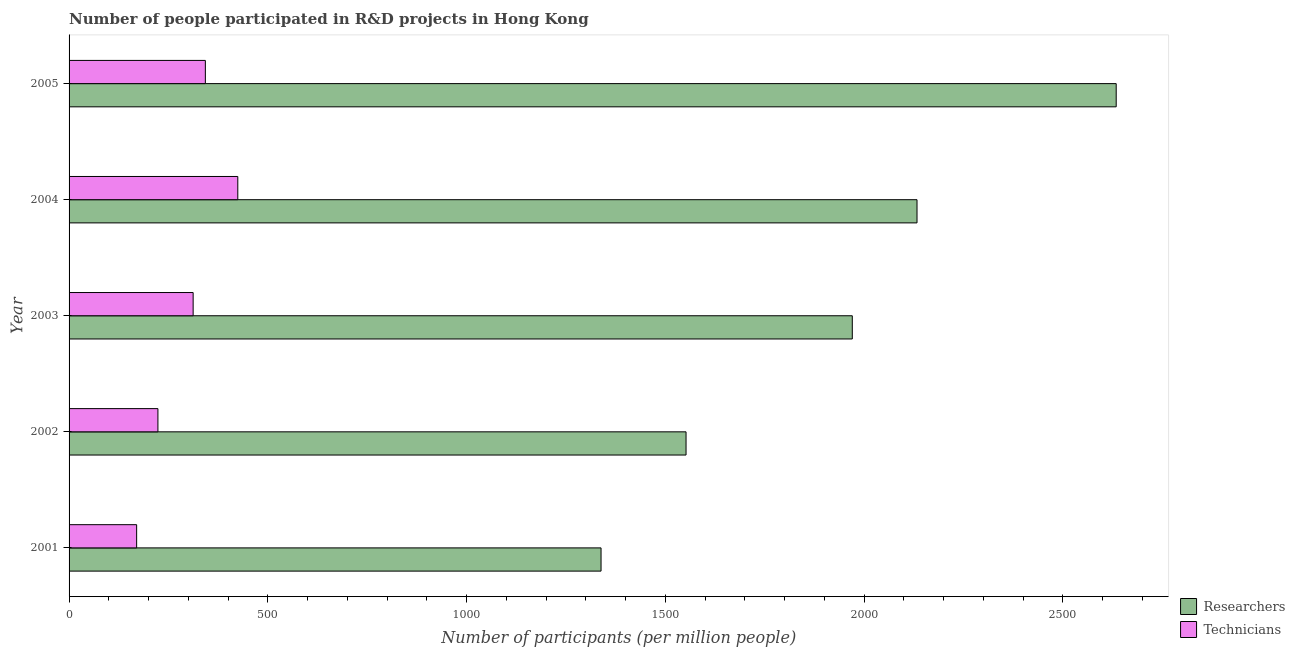How many different coloured bars are there?
Offer a very short reply. 2. How many groups of bars are there?
Provide a succinct answer. 5. How many bars are there on the 2nd tick from the top?
Provide a succinct answer. 2. How many bars are there on the 5th tick from the bottom?
Ensure brevity in your answer.  2. What is the label of the 3rd group of bars from the top?
Offer a very short reply. 2003. What is the number of researchers in 2004?
Keep it short and to the point. 2133.09. Across all years, what is the maximum number of researchers?
Offer a very short reply. 2634.14. Across all years, what is the minimum number of technicians?
Ensure brevity in your answer.  169.97. In which year was the number of technicians maximum?
Ensure brevity in your answer.  2004. What is the total number of researchers in the graph?
Provide a short and direct response. 9627.81. What is the difference between the number of researchers in 2003 and that in 2005?
Your answer should be very brief. -663.88. What is the difference between the number of researchers in 2004 and the number of technicians in 2001?
Your answer should be compact. 1963.12. What is the average number of technicians per year?
Ensure brevity in your answer.  294.58. In the year 2001, what is the difference between the number of technicians and number of researchers?
Your answer should be compact. -1168.28. In how many years, is the number of researchers greater than 600 ?
Give a very brief answer. 5. What is the ratio of the number of technicians in 2001 to that in 2003?
Your response must be concise. 0.55. What is the difference between the highest and the second highest number of technicians?
Keep it short and to the point. 81.6. What is the difference between the highest and the lowest number of technicians?
Your response must be concise. 254.49. What does the 1st bar from the top in 2005 represents?
Your answer should be very brief. Technicians. What does the 2nd bar from the bottom in 2002 represents?
Make the answer very short. Technicians. How many years are there in the graph?
Keep it short and to the point. 5. Does the graph contain any zero values?
Give a very brief answer. No. Does the graph contain grids?
Offer a terse response. No. How many legend labels are there?
Provide a short and direct response. 2. How are the legend labels stacked?
Offer a very short reply. Vertical. What is the title of the graph?
Provide a short and direct response. Number of people participated in R&D projects in Hong Kong. Does "From production" appear as one of the legend labels in the graph?
Your answer should be very brief. No. What is the label or title of the X-axis?
Make the answer very short. Number of participants (per million people). What is the label or title of the Y-axis?
Give a very brief answer. Year. What is the Number of participants (per million people) in Researchers in 2001?
Your response must be concise. 1338.25. What is the Number of participants (per million people) in Technicians in 2001?
Your answer should be very brief. 169.97. What is the Number of participants (per million people) in Researchers in 2002?
Your response must be concise. 1552.06. What is the Number of participants (per million people) in Technicians in 2002?
Offer a terse response. 223.49. What is the Number of participants (per million people) of Researchers in 2003?
Keep it short and to the point. 1970.26. What is the Number of participants (per million people) of Technicians in 2003?
Ensure brevity in your answer.  312.1. What is the Number of participants (per million people) of Researchers in 2004?
Offer a very short reply. 2133.09. What is the Number of participants (per million people) of Technicians in 2004?
Offer a terse response. 424.46. What is the Number of participants (per million people) in Researchers in 2005?
Offer a very short reply. 2634.14. What is the Number of participants (per million people) of Technicians in 2005?
Ensure brevity in your answer.  342.86. Across all years, what is the maximum Number of participants (per million people) in Researchers?
Offer a terse response. 2634.14. Across all years, what is the maximum Number of participants (per million people) in Technicians?
Provide a short and direct response. 424.46. Across all years, what is the minimum Number of participants (per million people) in Researchers?
Your response must be concise. 1338.25. Across all years, what is the minimum Number of participants (per million people) in Technicians?
Your answer should be very brief. 169.97. What is the total Number of participants (per million people) of Researchers in the graph?
Your answer should be very brief. 9627.81. What is the total Number of participants (per million people) of Technicians in the graph?
Your response must be concise. 1472.88. What is the difference between the Number of participants (per million people) of Researchers in 2001 and that in 2002?
Keep it short and to the point. -213.81. What is the difference between the Number of participants (per million people) in Technicians in 2001 and that in 2002?
Provide a short and direct response. -53.53. What is the difference between the Number of participants (per million people) of Researchers in 2001 and that in 2003?
Provide a succinct answer. -632.01. What is the difference between the Number of participants (per million people) in Technicians in 2001 and that in 2003?
Keep it short and to the point. -142.13. What is the difference between the Number of participants (per million people) in Researchers in 2001 and that in 2004?
Give a very brief answer. -794.84. What is the difference between the Number of participants (per million people) in Technicians in 2001 and that in 2004?
Offer a very short reply. -254.49. What is the difference between the Number of participants (per million people) of Researchers in 2001 and that in 2005?
Offer a very short reply. -1295.89. What is the difference between the Number of participants (per million people) in Technicians in 2001 and that in 2005?
Your answer should be very brief. -172.89. What is the difference between the Number of participants (per million people) of Researchers in 2002 and that in 2003?
Offer a terse response. -418.2. What is the difference between the Number of participants (per million people) in Technicians in 2002 and that in 2003?
Offer a terse response. -88.61. What is the difference between the Number of participants (per million people) of Researchers in 2002 and that in 2004?
Provide a short and direct response. -581.03. What is the difference between the Number of participants (per million people) of Technicians in 2002 and that in 2004?
Your response must be concise. -200.96. What is the difference between the Number of participants (per million people) in Researchers in 2002 and that in 2005?
Provide a short and direct response. -1082.08. What is the difference between the Number of participants (per million people) in Technicians in 2002 and that in 2005?
Give a very brief answer. -119.36. What is the difference between the Number of participants (per million people) of Researchers in 2003 and that in 2004?
Provide a short and direct response. -162.83. What is the difference between the Number of participants (per million people) of Technicians in 2003 and that in 2004?
Offer a very short reply. -112.36. What is the difference between the Number of participants (per million people) in Researchers in 2003 and that in 2005?
Offer a very short reply. -663.88. What is the difference between the Number of participants (per million people) in Technicians in 2003 and that in 2005?
Offer a very short reply. -30.76. What is the difference between the Number of participants (per million people) of Researchers in 2004 and that in 2005?
Your answer should be compact. -501.04. What is the difference between the Number of participants (per million people) of Technicians in 2004 and that in 2005?
Give a very brief answer. 81.6. What is the difference between the Number of participants (per million people) in Researchers in 2001 and the Number of participants (per million people) in Technicians in 2002?
Offer a very short reply. 1114.76. What is the difference between the Number of participants (per million people) of Researchers in 2001 and the Number of participants (per million people) of Technicians in 2003?
Your answer should be very brief. 1026.15. What is the difference between the Number of participants (per million people) in Researchers in 2001 and the Number of participants (per million people) in Technicians in 2004?
Your response must be concise. 913.79. What is the difference between the Number of participants (per million people) of Researchers in 2001 and the Number of participants (per million people) of Technicians in 2005?
Your response must be concise. 995.39. What is the difference between the Number of participants (per million people) of Researchers in 2002 and the Number of participants (per million people) of Technicians in 2003?
Offer a very short reply. 1239.96. What is the difference between the Number of participants (per million people) of Researchers in 2002 and the Number of participants (per million people) of Technicians in 2004?
Make the answer very short. 1127.61. What is the difference between the Number of participants (per million people) of Researchers in 2002 and the Number of participants (per million people) of Technicians in 2005?
Your answer should be very brief. 1209.2. What is the difference between the Number of participants (per million people) in Researchers in 2003 and the Number of participants (per million people) in Technicians in 2004?
Keep it short and to the point. 1545.81. What is the difference between the Number of participants (per million people) of Researchers in 2003 and the Number of participants (per million people) of Technicians in 2005?
Provide a succinct answer. 1627.4. What is the difference between the Number of participants (per million people) of Researchers in 2004 and the Number of participants (per million people) of Technicians in 2005?
Offer a terse response. 1790.24. What is the average Number of participants (per million people) in Researchers per year?
Provide a short and direct response. 1925.56. What is the average Number of participants (per million people) of Technicians per year?
Your answer should be very brief. 294.58. In the year 2001, what is the difference between the Number of participants (per million people) in Researchers and Number of participants (per million people) in Technicians?
Give a very brief answer. 1168.28. In the year 2002, what is the difference between the Number of participants (per million people) of Researchers and Number of participants (per million people) of Technicians?
Keep it short and to the point. 1328.57. In the year 2003, what is the difference between the Number of participants (per million people) in Researchers and Number of participants (per million people) in Technicians?
Ensure brevity in your answer.  1658.16. In the year 2004, what is the difference between the Number of participants (per million people) in Researchers and Number of participants (per million people) in Technicians?
Keep it short and to the point. 1708.64. In the year 2005, what is the difference between the Number of participants (per million people) of Researchers and Number of participants (per million people) of Technicians?
Provide a succinct answer. 2291.28. What is the ratio of the Number of participants (per million people) in Researchers in 2001 to that in 2002?
Offer a terse response. 0.86. What is the ratio of the Number of participants (per million people) of Technicians in 2001 to that in 2002?
Provide a short and direct response. 0.76. What is the ratio of the Number of participants (per million people) in Researchers in 2001 to that in 2003?
Your answer should be very brief. 0.68. What is the ratio of the Number of participants (per million people) in Technicians in 2001 to that in 2003?
Your answer should be compact. 0.54. What is the ratio of the Number of participants (per million people) of Researchers in 2001 to that in 2004?
Provide a short and direct response. 0.63. What is the ratio of the Number of participants (per million people) of Technicians in 2001 to that in 2004?
Give a very brief answer. 0.4. What is the ratio of the Number of participants (per million people) of Researchers in 2001 to that in 2005?
Offer a terse response. 0.51. What is the ratio of the Number of participants (per million people) in Technicians in 2001 to that in 2005?
Keep it short and to the point. 0.5. What is the ratio of the Number of participants (per million people) in Researchers in 2002 to that in 2003?
Your answer should be compact. 0.79. What is the ratio of the Number of participants (per million people) of Technicians in 2002 to that in 2003?
Keep it short and to the point. 0.72. What is the ratio of the Number of participants (per million people) in Researchers in 2002 to that in 2004?
Ensure brevity in your answer.  0.73. What is the ratio of the Number of participants (per million people) of Technicians in 2002 to that in 2004?
Offer a very short reply. 0.53. What is the ratio of the Number of participants (per million people) of Researchers in 2002 to that in 2005?
Provide a succinct answer. 0.59. What is the ratio of the Number of participants (per million people) of Technicians in 2002 to that in 2005?
Ensure brevity in your answer.  0.65. What is the ratio of the Number of participants (per million people) of Researchers in 2003 to that in 2004?
Provide a short and direct response. 0.92. What is the ratio of the Number of participants (per million people) in Technicians in 2003 to that in 2004?
Ensure brevity in your answer.  0.74. What is the ratio of the Number of participants (per million people) of Researchers in 2003 to that in 2005?
Your answer should be compact. 0.75. What is the ratio of the Number of participants (per million people) of Technicians in 2003 to that in 2005?
Your answer should be very brief. 0.91. What is the ratio of the Number of participants (per million people) in Researchers in 2004 to that in 2005?
Make the answer very short. 0.81. What is the ratio of the Number of participants (per million people) of Technicians in 2004 to that in 2005?
Provide a short and direct response. 1.24. What is the difference between the highest and the second highest Number of participants (per million people) of Researchers?
Give a very brief answer. 501.04. What is the difference between the highest and the second highest Number of participants (per million people) in Technicians?
Give a very brief answer. 81.6. What is the difference between the highest and the lowest Number of participants (per million people) of Researchers?
Provide a short and direct response. 1295.89. What is the difference between the highest and the lowest Number of participants (per million people) in Technicians?
Offer a terse response. 254.49. 